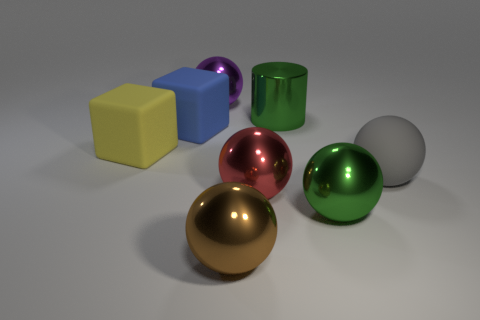The matte object that is to the right of the big yellow cube and on the left side of the big green metallic cylinder is what color?
Keep it short and to the point. Blue. There is a big cylinder; is it the same color as the big metallic ball that is on the right side of the green cylinder?
Ensure brevity in your answer.  Yes. How many other things are the same color as the big metallic cylinder?
Your answer should be compact. 1. Are there any large green metal objects behind the large blue rubber cube?
Keep it short and to the point. Yes. Is the size of the brown object the same as the green shiny object that is behind the gray rubber thing?
Make the answer very short. Yes. How many other things are there of the same material as the brown sphere?
Offer a terse response. 4. What shape is the large matte thing that is both on the right side of the yellow cube and on the left side of the big gray rubber thing?
Keep it short and to the point. Cube. There is a large gray object that is the same material as the big yellow thing; what is its shape?
Your answer should be very brief. Sphere. What is the color of the sphere behind the large rubber object that is on the right side of the metal object left of the big brown metallic object?
Provide a succinct answer. Purple. Are there fewer big matte cubes that are on the right side of the gray matte ball than big balls that are in front of the purple ball?
Your response must be concise. Yes. 